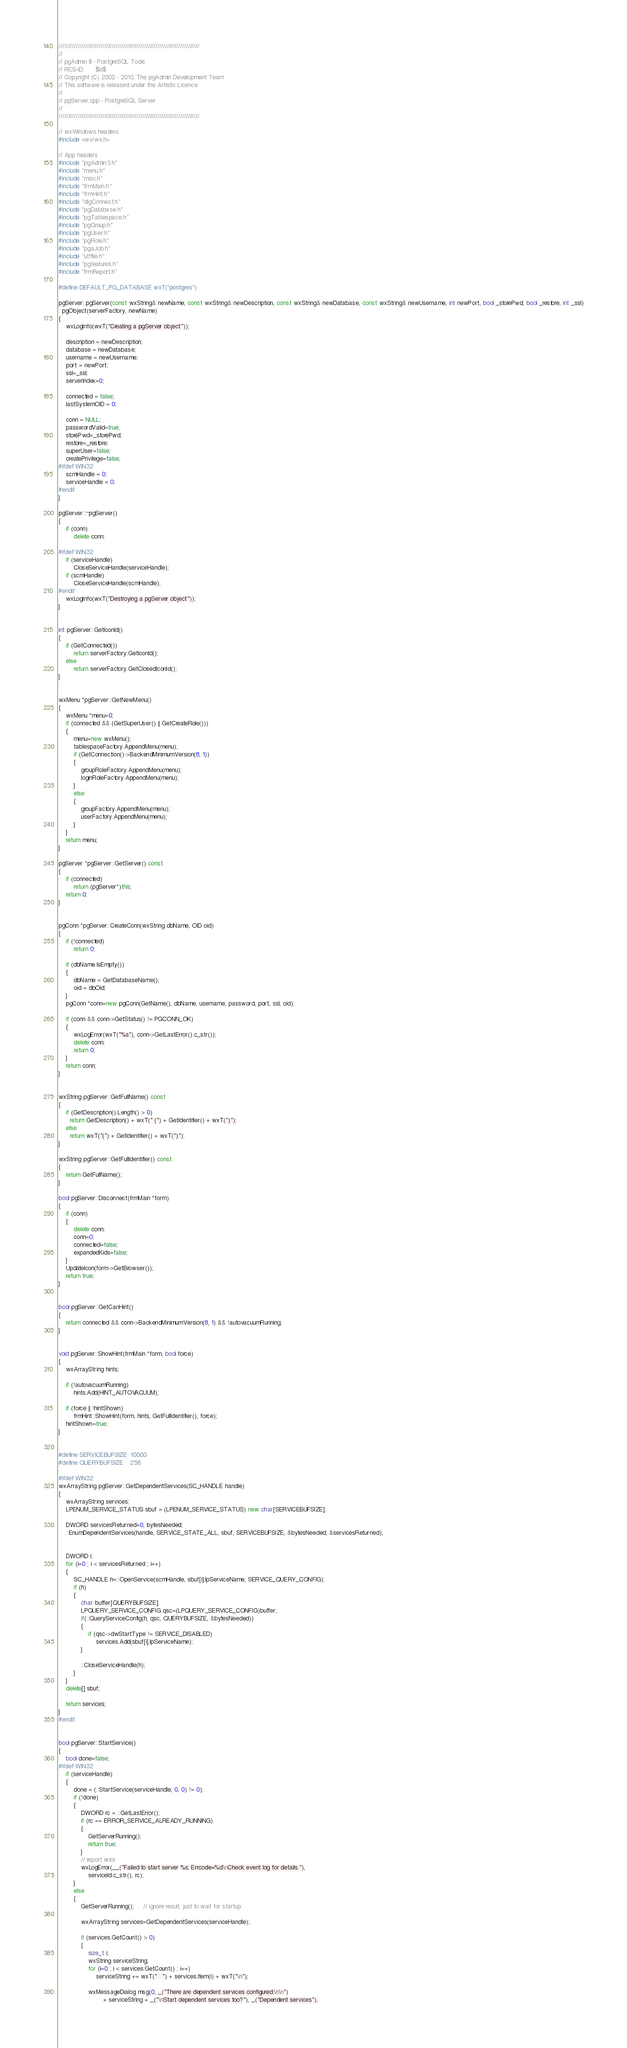Convert code to text. <code><loc_0><loc_0><loc_500><loc_500><_C++_>//////////////////////////////////////////////////////////////////////////
//
// pgAdmin III - PostgreSQL Tools
// RCS-ID:      $Id$
// Copyright (C) 2002 - 2010, The pgAdmin Development Team
// This software is released under the Artistic Licence
//
// pgServer.cpp - PostgreSQL Server
//
//////////////////////////////////////////////////////////////////////////

// wxWindows headers
#include <wx/wx.h>

// App headers
#include "pgAdmin3.h"
#include "menu.h"
#include "misc.h"
#include "frmMain.h"
#include "frmHint.h"
#include "dlgConnect.h"
#include "pgDatabase.h"
#include "pgTablespace.h"
#include "pgGroup.h"
#include "pgUser.h"
#include "pgRole.h"
#include "pgaJob.h"
#include "utffile.h"
#include "pgfeatures.h"
#include "frmReport.h"

#define DEFAULT_PG_DATABASE wxT("postgres")

pgServer::pgServer(const wxString& newName, const wxString& newDescription, const wxString& newDatabase, const wxString& newUsername, int newPort, bool _storePwd, bool _restore, int _ssl)
: pgObject(serverFactory, newName)
{  
    wxLogInfo(wxT("Creating a pgServer object"));

	description = newDescription;
    database = newDatabase;
    username = newUsername;
    port = newPort;
    ssl=_ssl;
    serverIndex=0;

    connected = false;
    lastSystemOID = 0;

    conn = NULL;
    passwordValid=true;
    storePwd=_storePwd;
	restore=_restore;
    superUser=false;
    createPrivilege=false;
#ifdef WIN32
    scmHandle = 0;
    serviceHandle = 0;
#endif
}

pgServer::~pgServer()
{
	if (conn)
		delete conn;

#ifdef WIN32
    if (serviceHandle)
        CloseServiceHandle(serviceHandle);
    if (scmHandle)
        CloseServiceHandle(scmHandle);
#endif
    wxLogInfo(wxT("Destroying a pgServer object"));
}


int pgServer::GetIconId()
{
    if (GetConnected())
        return serverFactory.GetIconId();
    else
        return serverFactory.GetClosedIconId();
}


wxMenu *pgServer::GetNewMenu()
{
    wxMenu *menu=0;
    if (connected && (GetSuperUser() || GetCreateRole()))
    {
        menu=new wxMenu();
        tablespaceFactory.AppendMenu(menu);
        if (GetConnection()->BackendMinimumVersion(8, 1))
        {
            groupRoleFactory.AppendMenu(menu);
            loginRoleFactory.AppendMenu(menu);
        }
        else
        {
            groupFactory.AppendMenu(menu);
            userFactory.AppendMenu(menu);
        }
    }
    return menu;
}

pgServer *pgServer::GetServer() const
{
    if (connected)
        return (pgServer*)this;
    return 0;
}


pgConn *pgServer::CreateConn(wxString dbName, OID oid)
{
    if (!connected)
        return 0;

    if (dbName.IsEmpty())
    {
        dbName = GetDatabaseName();
        oid = dbOid;
    }
    pgConn *conn=new pgConn(GetName(), dbName, username, password, port, ssl, oid);

    if (conn && conn->GetStatus() != PGCONN_OK)
    {
        wxLogError(wxT("%s"), conn->GetLastError().c_str());
        delete conn;
        return 0;
    }
    return conn;
}


wxString pgServer::GetFullName() const
{
    if (GetDescription().Length() > 0)
      return GetDescription() + wxT(" (") + GetIdentifier() + wxT(")");
    else
      return wxT("(") + GetIdentifier() + wxT(")");
}

wxString pgServer::GetFullIdentifier() const 
{
    return GetFullName();
}

bool pgServer::Disconnect(frmMain *form)
{
    if (conn)
    {
        delete conn;
        conn=0;
        connected=false;
        expandedKids=false;
    }
    UpdateIcon(form->GetBrowser());
    return true;
}


bool pgServer::GetCanHint()
{
    return connected && conn->BackendMinimumVersion(8, 1) && !autovacuumRunning;
}


void pgServer::ShowHint(frmMain *form, bool force)
{
    wxArrayString hints;

    if (!autovacuumRunning)
        hints.Add(HINT_AUTOVACUUM);
    
    if (force || !hintShown)
        frmHint::ShowHint(form, hints, GetFullIdentifier(), force);
    hintShown=true;
}


#define SERVICEBUFSIZE  10000
#define QUERYBUFSIZE    256     

#ifdef WIN32
wxArrayString pgServer::GetDependentServices(SC_HANDLE handle)
{
    wxArrayString services;
    LPENUM_SERVICE_STATUS sbuf = (LPENUM_SERVICE_STATUS) new char[SERVICEBUFSIZE];

    DWORD servicesReturned=0, bytesNeeded;
    ::EnumDependentServices(handle, SERVICE_STATE_ALL, sbuf, SERVICEBUFSIZE, &bytesNeeded, &servicesReturned);


    DWORD i;
    for (i=0 ; i < servicesReturned ; i++)
    {
        SC_HANDLE h=::OpenService(scmHandle, sbuf[i].lpServiceName, SERVICE_QUERY_CONFIG);
        if (h)
        {
            char buffer[QUERYBUFSIZE];
            LPQUERY_SERVICE_CONFIG qsc=(LPQUERY_SERVICE_CONFIG)buffer;
            if(::QueryServiceConfig(h, qsc, QUERYBUFSIZE, &bytesNeeded))
            {
                if (qsc->dwStartType != SERVICE_DISABLED)
                    services.Add(sbuf[i].lpServiceName);
            }

            ::CloseServiceHandle(h);
        }
    }
    delete[] sbuf;

    return services;
}
#endif


bool pgServer::StartService()
{
    bool done=false;
#ifdef WIN32
    if (serviceHandle)
    {
        done = (::StartService(serviceHandle, 0, 0) != 0);
        if (!done)
        {
            DWORD rc = ::GetLastError();
            if (rc == ERROR_SERVICE_ALREADY_RUNNING)
            {
                GetServerRunning();
                return true;
            }
            // report error
            wxLogError(__("Failed to start server %s: Errcode=%d\nCheck event log for details."),
                serviceId.c_str(), rc);
        }
        else
        {
            GetServerRunning();     // ignore result, just to wait for startup

            wxArrayString services=GetDependentServices(serviceHandle);

            if (services.GetCount() > 0)
            {
                size_t i;
                wxString serviceString;
                for (i=0 ; i < services.GetCount() ; i++)
                    serviceString += wxT("   ") + services.Item(i) + wxT("\n");

                wxMessageDialog msg(0, _("There are dependent services configured:\n\n")
                        + serviceString + _("\nStart dependent services too?"), _("Dependent services"),</code> 